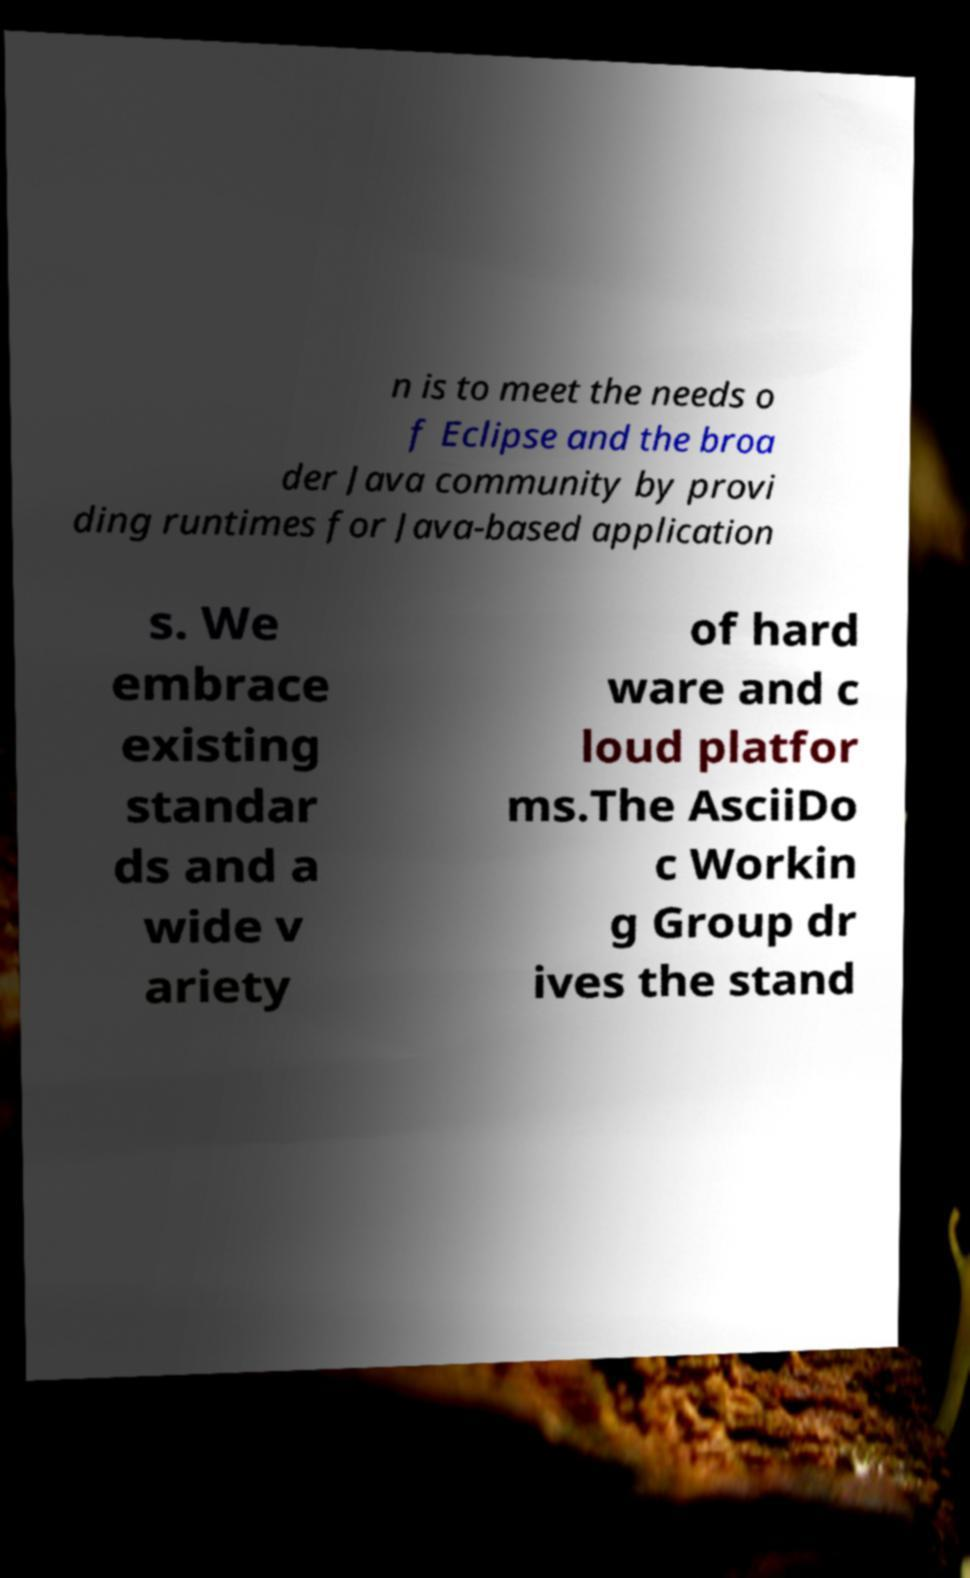Can you read and provide the text displayed in the image?This photo seems to have some interesting text. Can you extract and type it out for me? n is to meet the needs o f Eclipse and the broa der Java community by provi ding runtimes for Java-based application s. We embrace existing standar ds and a wide v ariety of hard ware and c loud platfor ms.The AsciiDo c Workin g Group dr ives the stand 